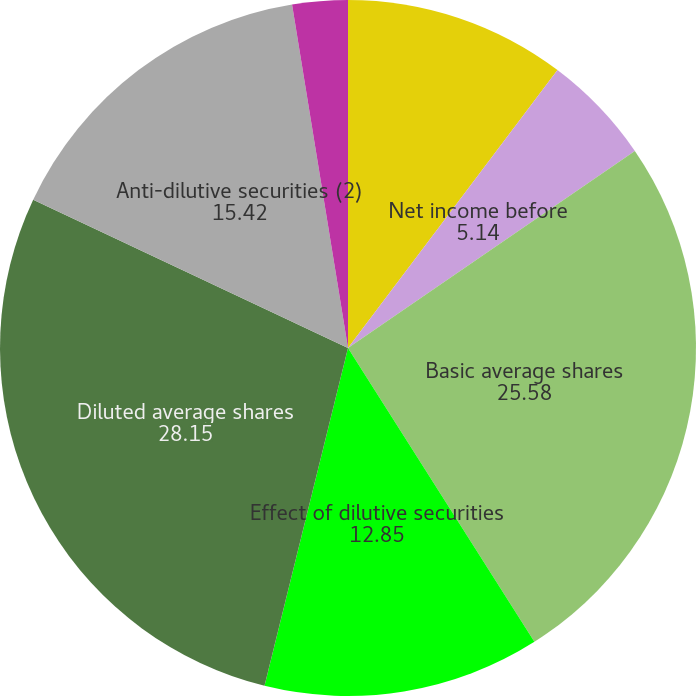Convert chart to OTSL. <chart><loc_0><loc_0><loc_500><loc_500><pie_chart><fcel>(Dollars in millions except<fcel>Net income before<fcel>Basic average shares<fcel>Effect of dilutive securities<fcel>Diluted average shares<fcel>Anti-dilutive securities (2)<fcel>Basic<fcel>Diluted (3)<nl><fcel>10.28%<fcel>5.14%<fcel>25.58%<fcel>12.85%<fcel>28.15%<fcel>15.42%<fcel>2.57%<fcel>0.0%<nl></chart> 